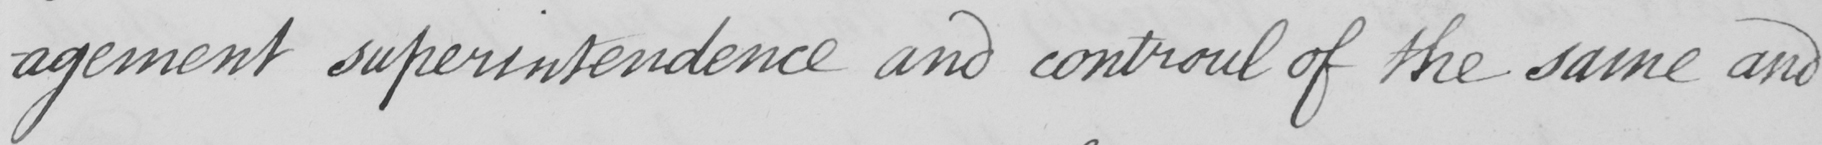Transcribe the text shown in this historical manuscript line. -agement superintendence and controul of the same and 